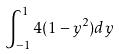Convert formula to latex. <formula><loc_0><loc_0><loc_500><loc_500>\int _ { - 1 } ^ { 1 } 4 ( 1 - y ^ { 2 } ) d y</formula> 